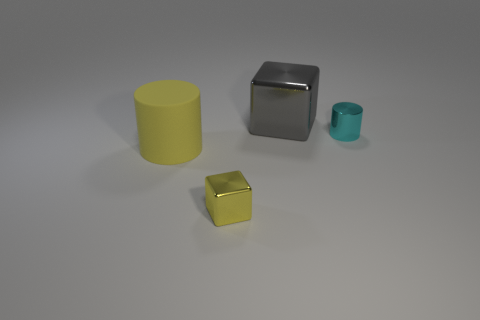Are there any other things that have the same material as the large yellow cylinder?
Provide a short and direct response. No. What number of other small metal things have the same shape as the gray shiny thing?
Keep it short and to the point. 1. Are there more things that are right of the matte thing than tiny blue matte balls?
Make the answer very short. Yes. What shape is the small object that is left of the big object that is right of the tiny shiny object that is left of the tiny cyan metal cylinder?
Give a very brief answer. Cube. There is a big object that is in front of the large metal cube; is it the same shape as the tiny thing that is behind the large rubber object?
Your answer should be very brief. Yes. How many cylinders are either small cyan metal things or big purple objects?
Provide a succinct answer. 1. Do the small cylinder and the gray thing have the same material?
Offer a terse response. Yes. What number of other objects are there of the same color as the large block?
Provide a short and direct response. 0. What is the shape of the large thing that is in front of the cyan shiny cylinder?
Your answer should be very brief. Cylinder. How many things are either large purple metal balls or large gray blocks?
Offer a very short reply. 1. 